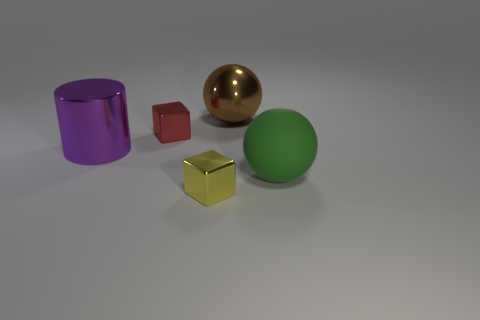Subtract all cubes. How many objects are left? 3 Subtract all red blocks. How many blocks are left? 1 Subtract 1 balls. How many balls are left? 1 Subtract all cyan cylinders. How many green blocks are left? 0 Subtract all red balls. Subtract all red things. How many objects are left? 4 Add 1 tiny yellow metal blocks. How many tiny yellow metal blocks are left? 2 Add 1 tiny gray cylinders. How many tiny gray cylinders exist? 1 Add 3 big blue metal cylinders. How many objects exist? 8 Subtract 1 purple cylinders. How many objects are left? 4 Subtract all cyan cylinders. Subtract all blue spheres. How many cylinders are left? 1 